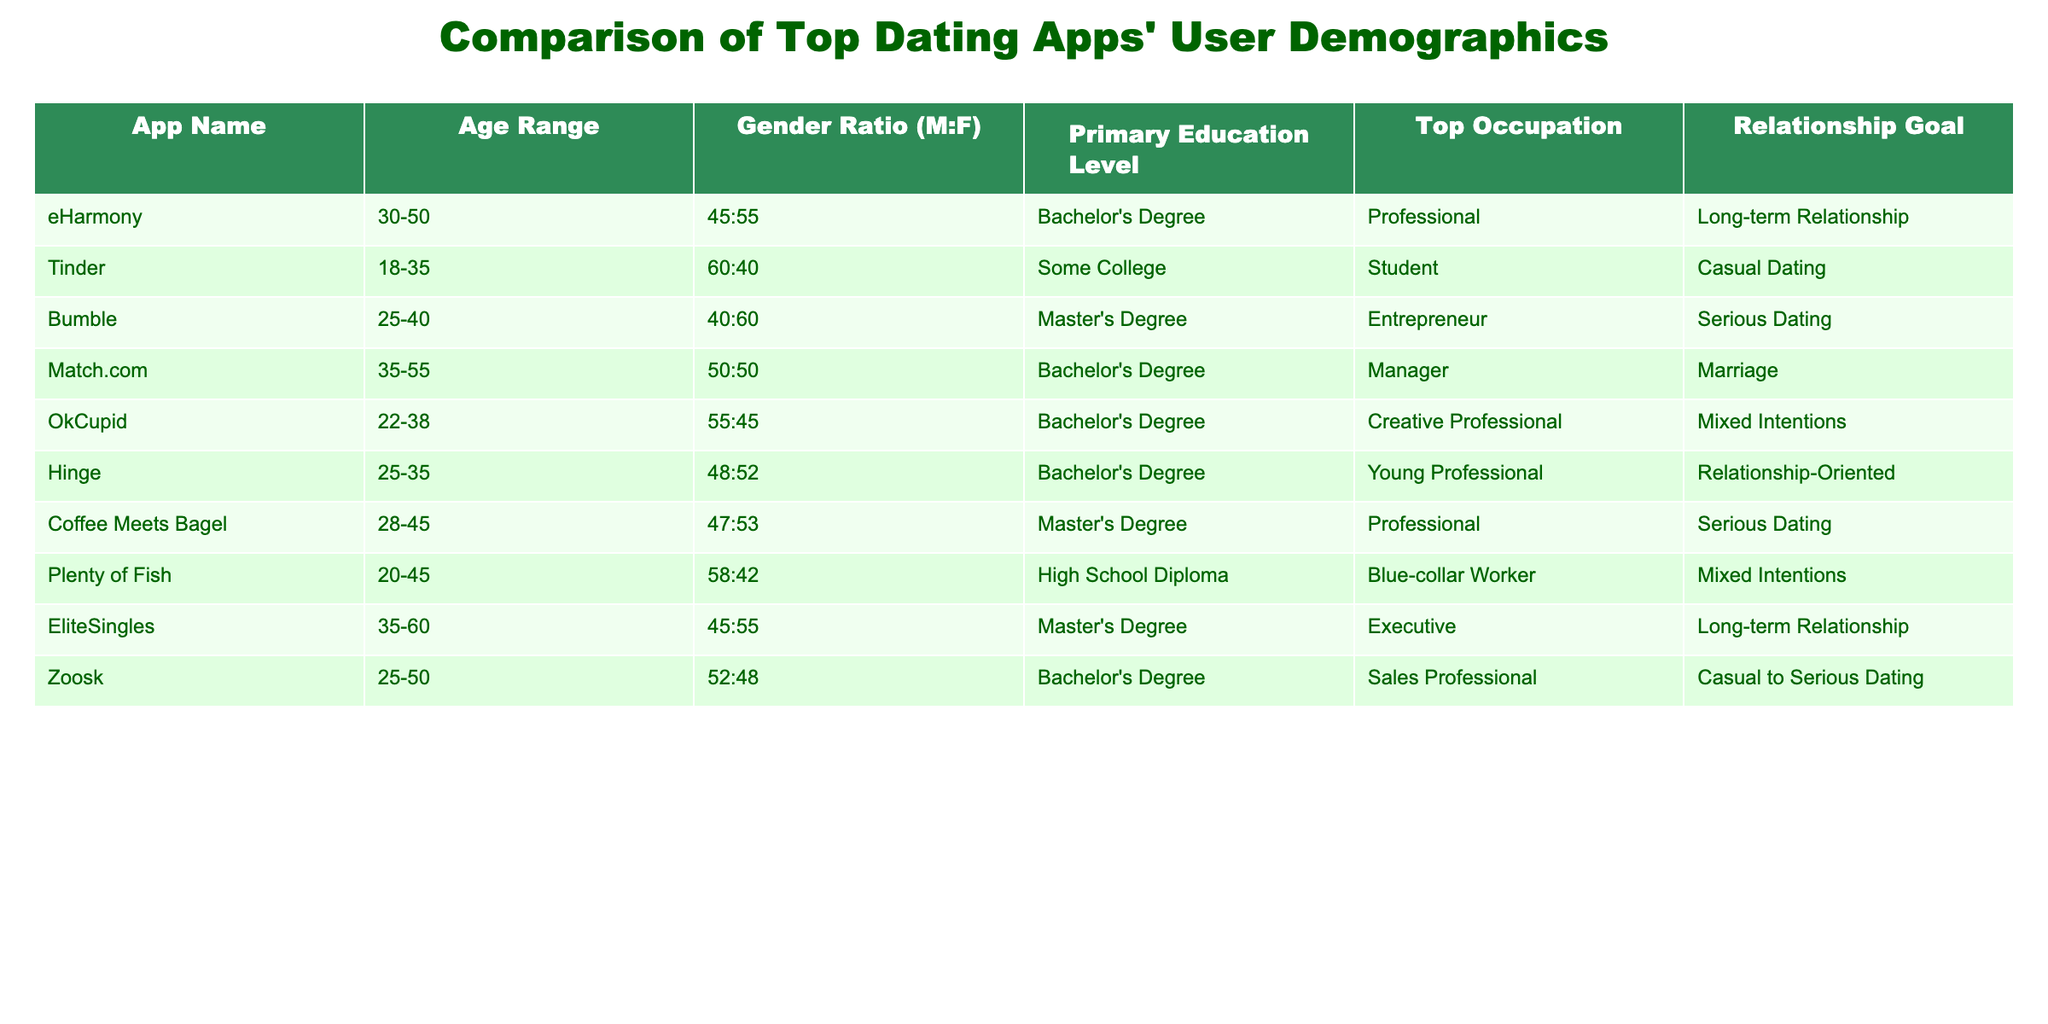What is the age range of users on eHarmony? According to the table, the age range of users on eHarmony is clearly displayed under the 'Age Range' column. It states "30-50".
Answer: 30-50 Which dating app has the highest gender ratio of males to females? By comparing the gender ratios listed, Tinder shows a 60:40 ratio. This is higher than the other apps in the table.
Answer: Tinder What is the primary education level of users on Plenty of Fish? The table indicates the primary education level for Plenty of Fish in the respective column, which states "High School Diploma".
Answer: High School Diploma How many dating apps have a primarily serious dating relationship goal? Reviewing the 'Relationship Goal' column, Bumble, Coffee Meets Bagel, and Match.com are identified as having a primary focus on serious dating, totaling three apps.
Answer: Three Is the majority of eHarmony's user base professional according to their top occupation? The table lists "Professional" as the top occupation for eHarmony, which supports this claim. Therefore, yes, the majority can be seen as professional.
Answer: Yes What is the average age range of users across these dating apps? The age ranges for each app vary. Summarizing for a rough average: (30 + 35 + 25 + 35 + 22 + 25 + 28 + 20 + 35 + 25) / 10 = 26.5 for lower limits and (50 + 55 + 40 + 55 + 38 + 35 + 45 + 45 + 60 + 50) / 10 = 48 for upper limits. This indicates an overall average age range of approximately 26.5-48.
Answer: 26.5-48 Which dating app has the lowest gender ratio of males to females? By examining the gender ratios, Plenty of Fish at 58:42 shows the lowest balance compared to others. Hence it has a higher proportion of females than males.
Answer: Plenty of Fish What percentage of the user base on OkCupid has a Bachelor's Degree? The data indicates that "Bachelor's Degree" is listed as the primary education level for OkCupid. Since no percentages provided, we cannot derive an exact percentage.
Answer: Cannot be determined Which dating app is primarily tailored for casual dating based on user demographics? The table specifically lists Tinder as targeting casual dating alongside Zoosk that offers a mix of intents, leading to the identification of Tinder as the primary app for casual dating.
Answer: Tinder Does Coffee Meets Bagel attract predominantly male users? The gender ratio provided is 47:53, indicating a majority of female users. Therefore, it does not predominantly attract male users.
Answer: No Based on the data, what is the most common relationship goal among the apps listed? Evaluating the 'Relationship Goal' column, "Long-term Relationship" shows up twice under eHarmony and EliteSingles compared to the other relationship goals, marking it as the most common overall.
Answer: Long-term Relationship 